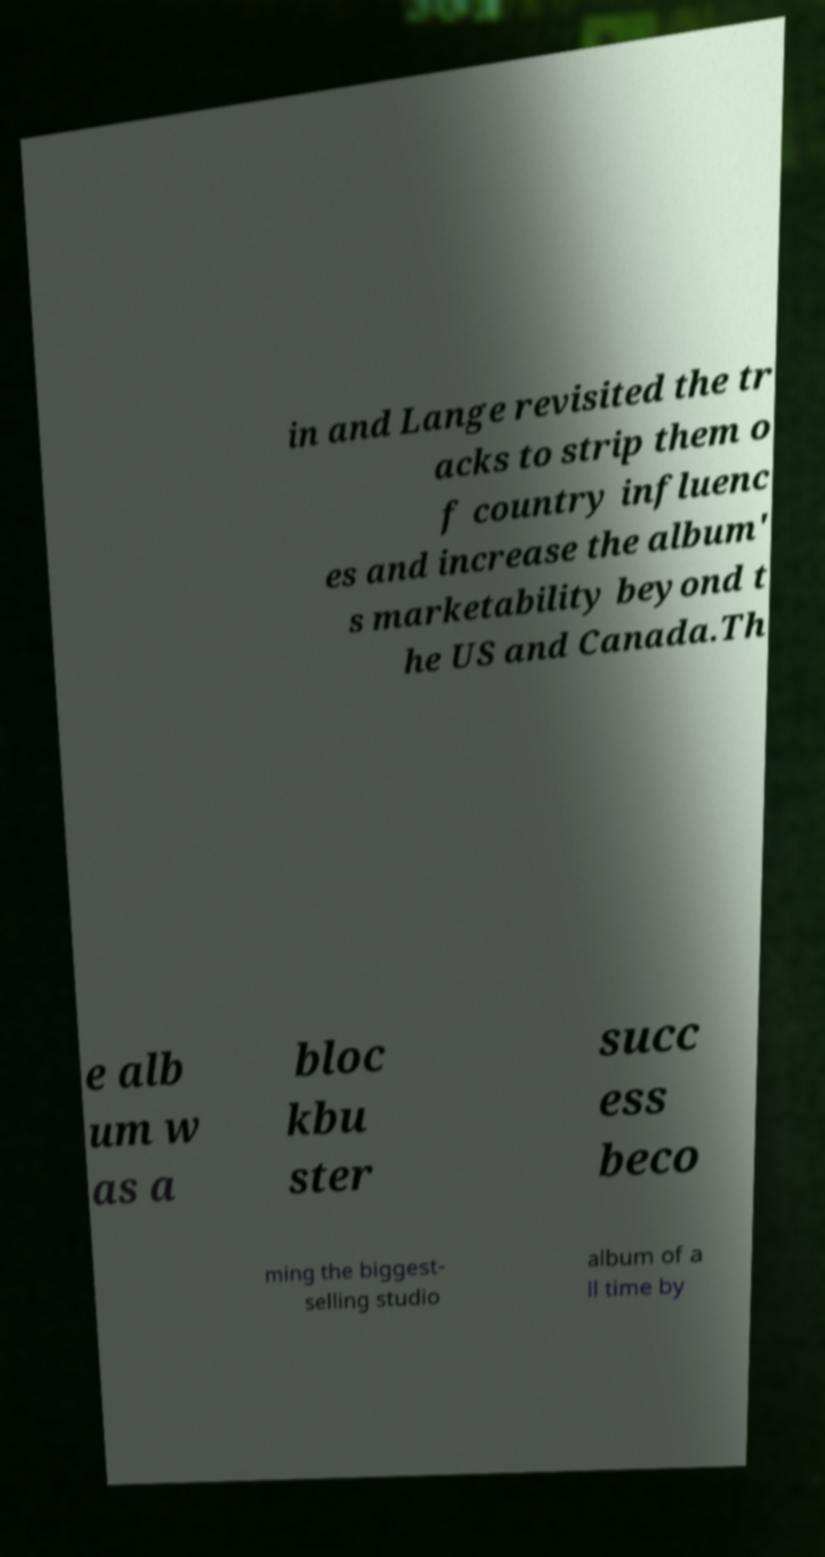Please identify and transcribe the text found in this image. in and Lange revisited the tr acks to strip them o f country influenc es and increase the album' s marketability beyond t he US and Canada.Th e alb um w as a bloc kbu ster succ ess beco ming the biggest- selling studio album of a ll time by 